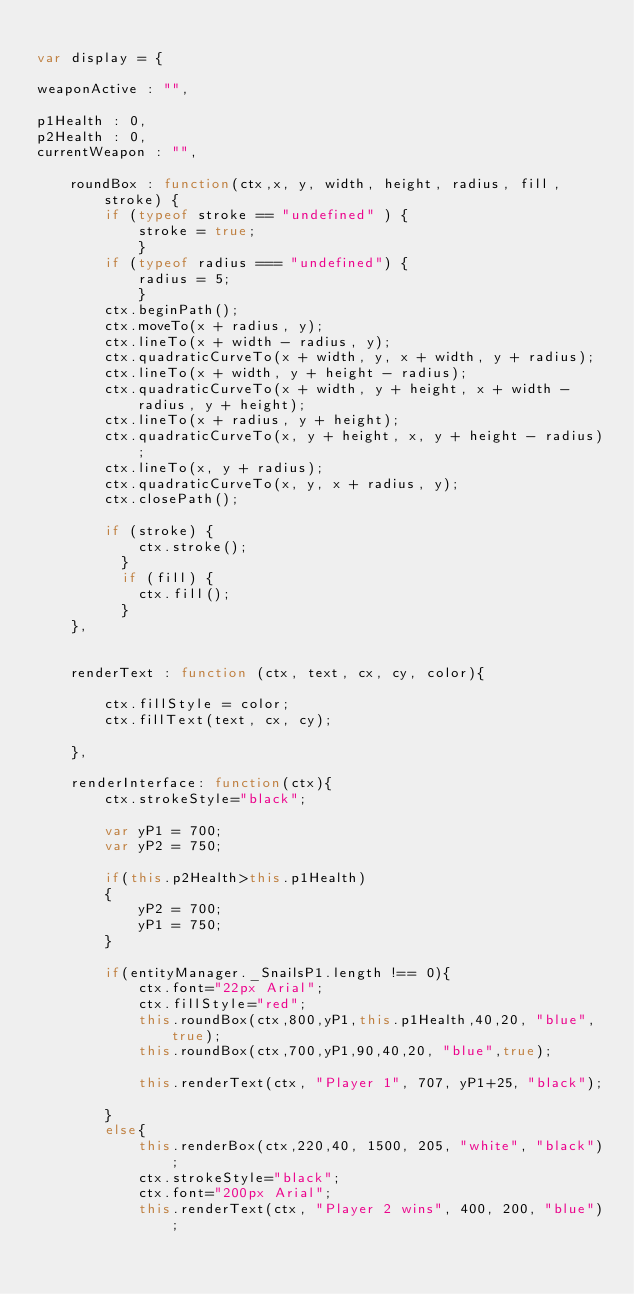<code> <loc_0><loc_0><loc_500><loc_500><_JavaScript_>
var display = {

weaponActive : "",

p1Health : 0,
p2Health : 0,
currentWeapon : "",

	roundBox : function(ctx,x, y, width, height, radius, fill, stroke) {
		if (typeof stroke == "undefined" ) {
			stroke = true;
			}
		if (typeof radius === "undefined") {
			radius = 5;
			}
		ctx.beginPath();
		ctx.moveTo(x + radius, y);
		ctx.lineTo(x + width - radius, y);
		ctx.quadraticCurveTo(x + width, y, x + width, y + radius);
		ctx.lineTo(x + width, y + height - radius);
		ctx.quadraticCurveTo(x + width, y + height, x + width - radius, y + height);
		ctx.lineTo(x + radius, y + height);
		ctx.quadraticCurveTo(x, y + height, x, y + height - radius);
		ctx.lineTo(x, y + radius);
		ctx.quadraticCurveTo(x, y, x + radius, y);
		ctx.closePath();
		
		if (stroke) {
			ctx.stroke();
		  }
		  if (fill) {
			ctx.fill();
		  }        
	},


	renderText : function (ctx, text, cx, cy, color){
		
		ctx.fillStyle = color;
		ctx.fillText(text, cx, cy);
		
	},
	
	renderInterface: function(ctx){
		ctx.strokeStyle="black";
		
		var yP1 = 700;
		var yP2 = 750;
		
		if(this.p2Health>this.p1Health)
		{
			yP2 = 700;
			yP1 = 750;
		}
		
		if(entityManager._SnailsP1.length !== 0){
			ctx.font="22px Arial";
			ctx.fillStyle="red";
			this.roundBox(ctx,800,yP1,this.p1Health,40,20, "blue",true);
			this.roundBox(ctx,700,yP1,90,40,20, "blue",true);
			
			this.renderText(ctx, "Player 1", 707, yP1+25, "black");
			
		}
		else{
			this.renderBox(ctx,220,40, 1500, 205, "white", "black");
			ctx.strokeStyle="black";
			ctx.font="200px Arial";	
			this.renderText(ctx, "Player 2 wins", 400, 200, "blue");</code> 